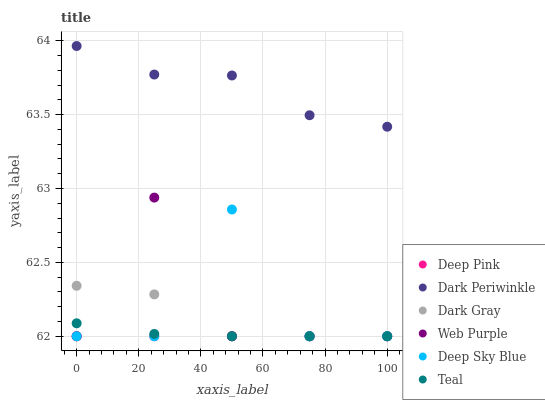Does Deep Pink have the minimum area under the curve?
Answer yes or no. Yes. Does Dark Periwinkle have the maximum area under the curve?
Answer yes or no. Yes. Does Deep Sky Blue have the minimum area under the curve?
Answer yes or no. No. Does Deep Sky Blue have the maximum area under the curve?
Answer yes or no. No. Is Deep Pink the smoothest?
Answer yes or no. Yes. Is Deep Sky Blue the roughest?
Answer yes or no. Yes. Is Dark Gray the smoothest?
Answer yes or no. No. Is Dark Gray the roughest?
Answer yes or no. No. Does Deep Pink have the lowest value?
Answer yes or no. Yes. Does Dark Periwinkle have the lowest value?
Answer yes or no. No. Does Dark Periwinkle have the highest value?
Answer yes or no. Yes. Does Deep Sky Blue have the highest value?
Answer yes or no. No. Is Web Purple less than Dark Periwinkle?
Answer yes or no. Yes. Is Dark Periwinkle greater than Deep Pink?
Answer yes or no. Yes. Does Deep Sky Blue intersect Teal?
Answer yes or no. Yes. Is Deep Sky Blue less than Teal?
Answer yes or no. No. Is Deep Sky Blue greater than Teal?
Answer yes or no. No. Does Web Purple intersect Dark Periwinkle?
Answer yes or no. No. 